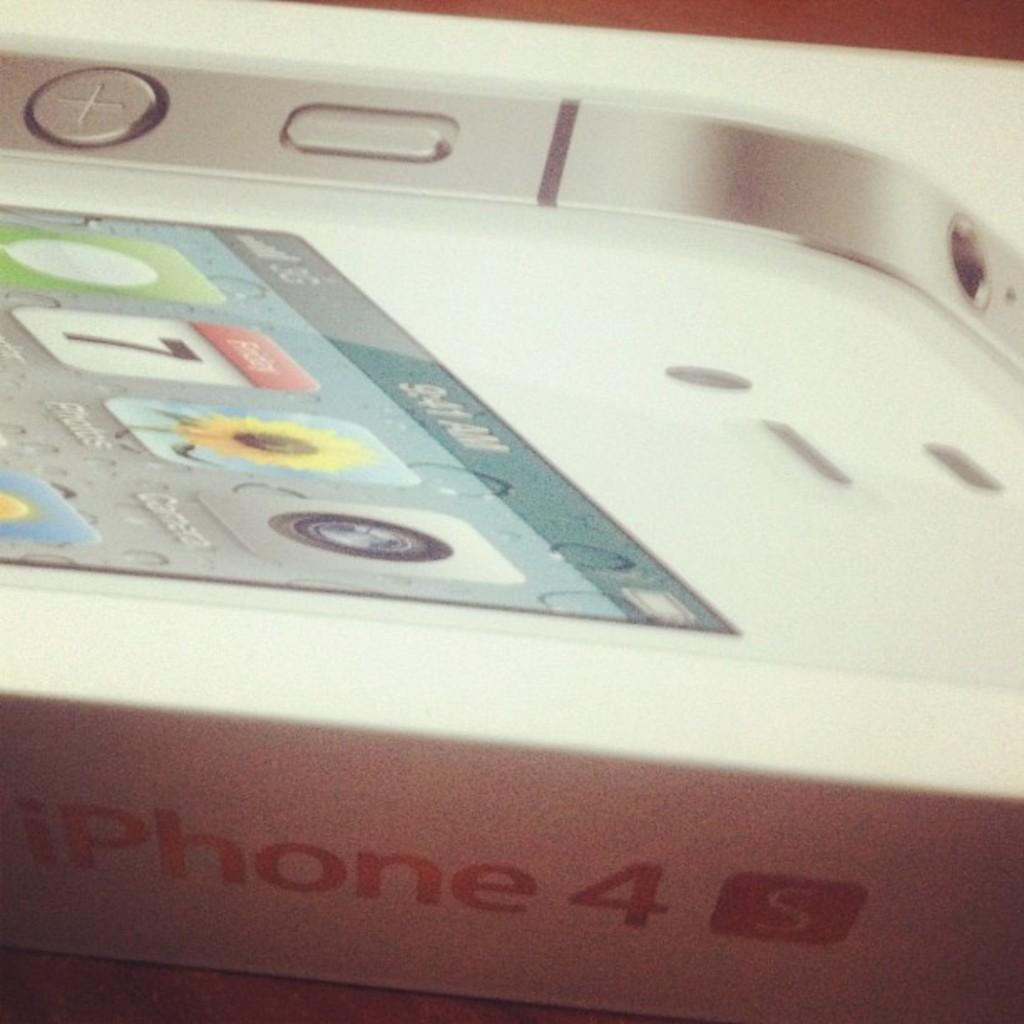<image>
Describe the image concisely. The box from a new iPhone 4 with the cover showing apps. 